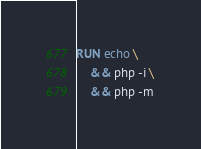Convert code to text. <code><loc_0><loc_0><loc_500><loc_500><_Dockerfile_>RUN echo \
    && php -i \
    && php -m</code> 